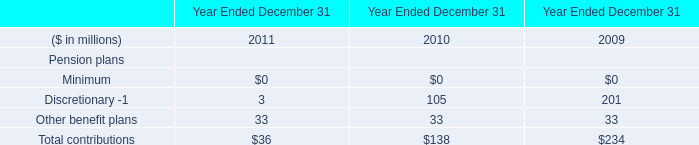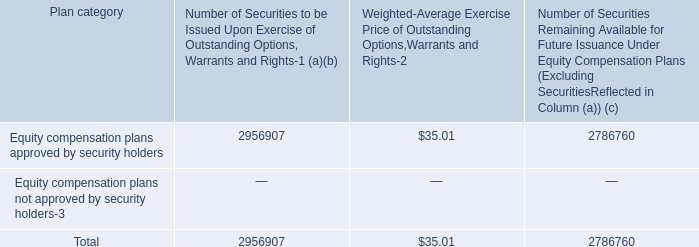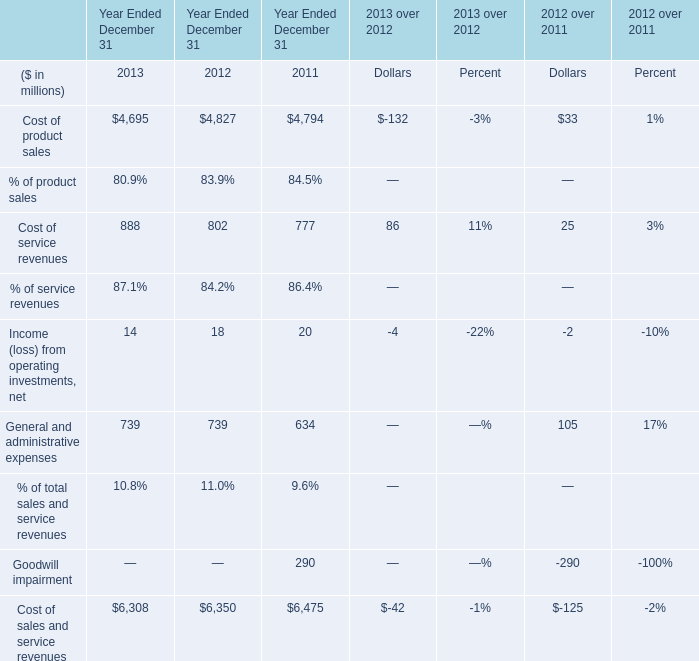What is the average value of Goodwill impairment in Table 2 and Total contributions in Table 0 in 2011? (in million) 
Computations: ((290 + 36) / 2)
Answer: 163.0. 